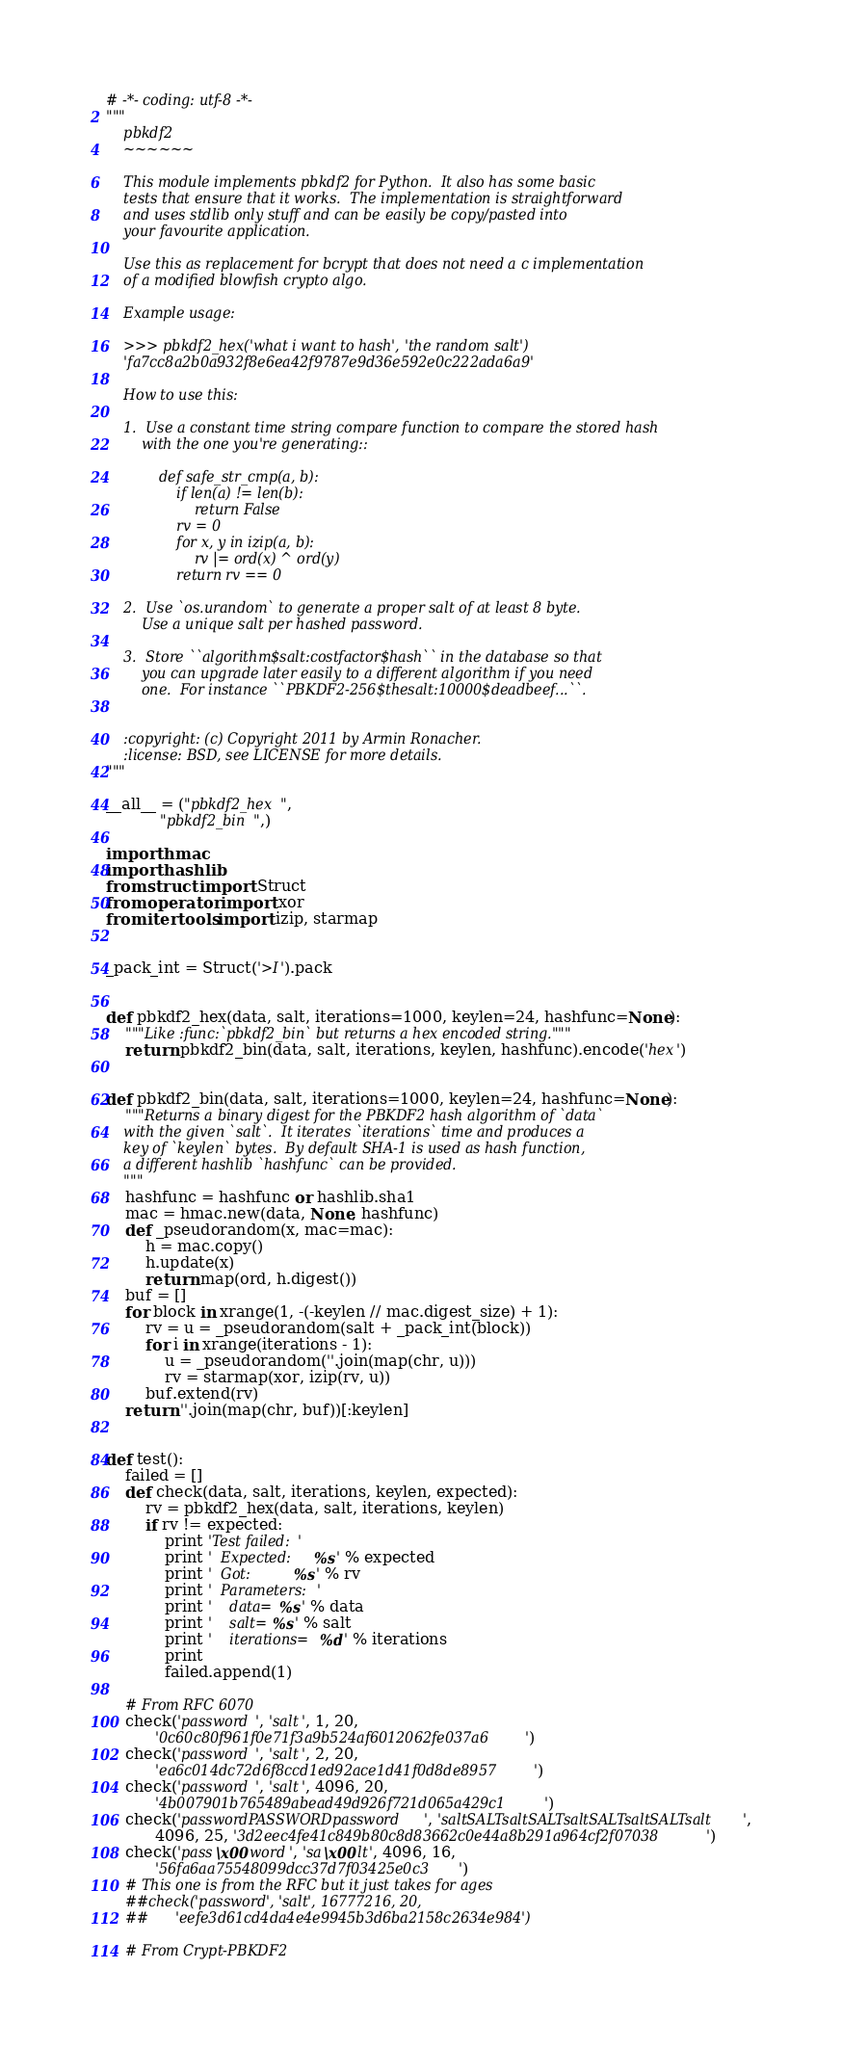<code> <loc_0><loc_0><loc_500><loc_500><_Python_># -*- coding: utf-8 -*-
"""
    pbkdf2
    ~~~~~~

    This module implements pbkdf2 for Python.  It also has some basic
    tests that ensure that it works.  The implementation is straightforward
    and uses stdlib only stuff and can be easily be copy/pasted into
    your favourite application.

    Use this as replacement for bcrypt that does not need a c implementation
    of a modified blowfish crypto algo.

    Example usage:

    >>> pbkdf2_hex('what i want to hash', 'the random salt')
    'fa7cc8a2b0a932f8e6ea42f9787e9d36e592e0c222ada6a9'

    How to use this:

    1.  Use a constant time string compare function to compare the stored hash
        with the one you're generating::

            def safe_str_cmp(a, b):
                if len(a) != len(b):
                    return False
                rv = 0
                for x, y in izip(a, b):
                    rv |= ord(x) ^ ord(y)
                return rv == 0

    2.  Use `os.urandom` to generate a proper salt of at least 8 byte.
        Use a unique salt per hashed password.

    3.  Store ``algorithm$salt:costfactor$hash`` in the database so that
        you can upgrade later easily to a different algorithm if you need
        one.  For instance ``PBKDF2-256$thesalt:10000$deadbeef...``.


    :copyright: (c) Copyright 2011 by Armin Ronacher.
    :license: BSD, see LICENSE for more details.
"""

__all__ = ("pbkdf2_hex",
           "pbkdf2_bin",)

import hmac
import hashlib
from struct import Struct
from operator import xor
from itertools import izip, starmap


_pack_int = Struct('>I').pack


def pbkdf2_hex(data, salt, iterations=1000, keylen=24, hashfunc=None):
    """Like :func:`pbkdf2_bin` but returns a hex encoded string."""
    return pbkdf2_bin(data, salt, iterations, keylen, hashfunc).encode('hex')


def pbkdf2_bin(data, salt, iterations=1000, keylen=24, hashfunc=None):
    """Returns a binary digest for the PBKDF2 hash algorithm of `data`
    with the given `salt`.  It iterates `iterations` time and produces a
    key of `keylen` bytes.  By default SHA-1 is used as hash function,
    a different hashlib `hashfunc` can be provided.
    """
    hashfunc = hashfunc or hashlib.sha1
    mac = hmac.new(data, None, hashfunc)
    def _pseudorandom(x, mac=mac):
        h = mac.copy()
        h.update(x)
        return map(ord, h.digest())
    buf = []
    for block in xrange(1, -(-keylen // mac.digest_size) + 1):
        rv = u = _pseudorandom(salt + _pack_int(block))
        for i in xrange(iterations - 1):
            u = _pseudorandom(''.join(map(chr, u)))
            rv = starmap(xor, izip(rv, u))
        buf.extend(rv)
    return ''.join(map(chr, buf))[:keylen]


def test():
    failed = []
    def check(data, salt, iterations, keylen, expected):
        rv = pbkdf2_hex(data, salt, iterations, keylen)
        if rv != expected:
            print 'Test failed:'
            print '  Expected:   %s' % expected
            print '  Got:        %s' % rv
            print '  Parameters:'
            print '    data=%s' % data
            print '    salt=%s' % salt
            print '    iterations=%d' % iterations
            print
            failed.append(1)

    # From RFC 6070
    check('password', 'salt', 1, 20,
          '0c60c80f961f0e71f3a9b524af6012062fe037a6')
    check('password', 'salt', 2, 20,
          'ea6c014dc72d6f8ccd1ed92ace1d41f0d8de8957')
    check('password', 'salt', 4096, 20,
          '4b007901b765489abead49d926f721d065a429c1')
    check('passwordPASSWORDpassword', 'saltSALTsaltSALTsaltSALTsaltSALTsalt',
          4096, 25, '3d2eec4fe41c849b80c8d83662c0e44a8b291a964cf2f07038')
    check('pass\x00word', 'sa\x00lt', 4096, 16,
          '56fa6aa75548099dcc37d7f03425e0c3')
    # This one is from the RFC but it just takes for ages
    ##check('password', 'salt', 16777216, 20,
    ##      'eefe3d61cd4da4e4e9945b3d6ba2158c2634e984')

    # From Crypt-PBKDF2</code> 